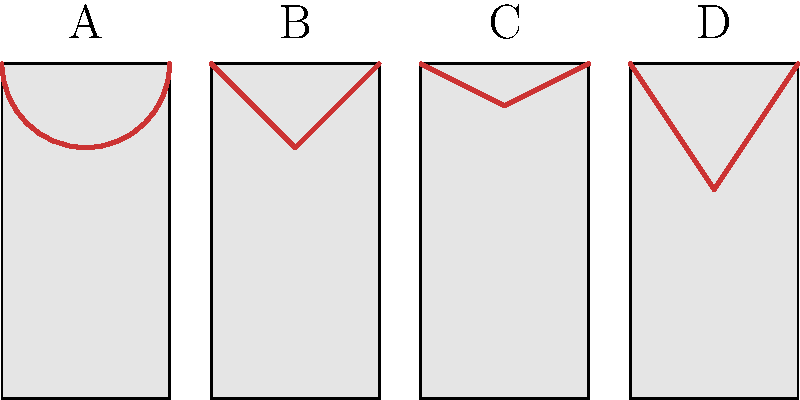Identify the neckline styles shown in the silhouette diagrams of vintage gowns labeled A, B, C, and D. To identify the neckline styles, we need to analyze the shapes at the top of each dress silhouette:

1. Neckline A: This neckline shows a curved, semi-circular shape that extends across the entire width of the bodice. This is characteristic of a Scoop neckline, which is a classic and versatile style often found in vintage gowns.

2. Neckline B: The neckline forms a distinct V-shape, with straight lines meeting at a point in the center. This is a clear representation of a V-neck, a timeless style that was particularly popular in vintage evening gowns of the 1930s and 1940s.

3. Neckline C: This neckline has a gentle curved shape that is wider and shallower than the scoop neck. It forms a subtle U-shape across the chest. This style is known as a Sweetheart neckline, which was very popular in vintage gowns from the 1950s.

4. Neckline D: The neckline here forms a deep V-shape, but with slightly curved edges rather than straight lines. This dramatic plunge is characteristic of a Plunging neckline, which became more common in vintage gowns from the late 1960s and 1970s.
Answer: A: Scoop, B: V-neck, C: Sweetheart, D: Plunging 